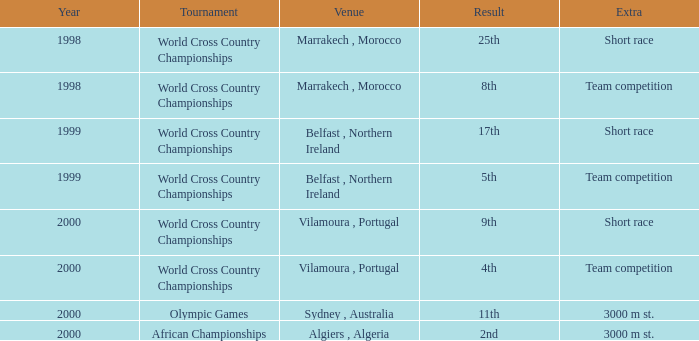Where did the extra short race take place, in a year prior to 1999? Marrakech , Morocco. 